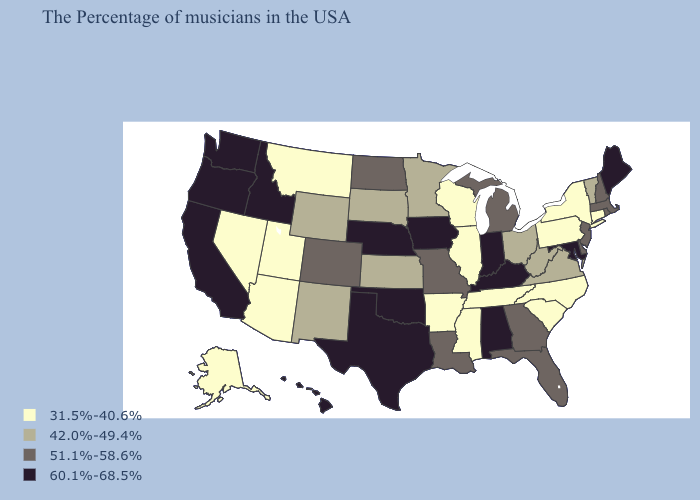What is the lowest value in the USA?
Write a very short answer. 31.5%-40.6%. Name the states that have a value in the range 60.1%-68.5%?
Keep it brief. Maine, Maryland, Kentucky, Indiana, Alabama, Iowa, Nebraska, Oklahoma, Texas, Idaho, California, Washington, Oregon, Hawaii. Which states have the lowest value in the Northeast?
Short answer required. Connecticut, New York, Pennsylvania. Name the states that have a value in the range 42.0%-49.4%?
Give a very brief answer. Vermont, Virginia, West Virginia, Ohio, Minnesota, Kansas, South Dakota, Wyoming, New Mexico. Is the legend a continuous bar?
Give a very brief answer. No. What is the value of South Dakota?
Write a very short answer. 42.0%-49.4%. Among the states that border Minnesota , which have the highest value?
Write a very short answer. Iowa. Name the states that have a value in the range 42.0%-49.4%?
Short answer required. Vermont, Virginia, West Virginia, Ohio, Minnesota, Kansas, South Dakota, Wyoming, New Mexico. Does Nebraska have the same value as Oregon?
Short answer required. Yes. Which states have the lowest value in the USA?
Write a very short answer. Connecticut, New York, Pennsylvania, North Carolina, South Carolina, Tennessee, Wisconsin, Illinois, Mississippi, Arkansas, Utah, Montana, Arizona, Nevada, Alaska. Which states have the lowest value in the West?
Quick response, please. Utah, Montana, Arizona, Nevada, Alaska. Does the map have missing data?
Keep it brief. No. What is the highest value in the Northeast ?
Keep it brief. 60.1%-68.5%. Which states have the highest value in the USA?
Concise answer only. Maine, Maryland, Kentucky, Indiana, Alabama, Iowa, Nebraska, Oklahoma, Texas, Idaho, California, Washington, Oregon, Hawaii. Name the states that have a value in the range 31.5%-40.6%?
Short answer required. Connecticut, New York, Pennsylvania, North Carolina, South Carolina, Tennessee, Wisconsin, Illinois, Mississippi, Arkansas, Utah, Montana, Arizona, Nevada, Alaska. 